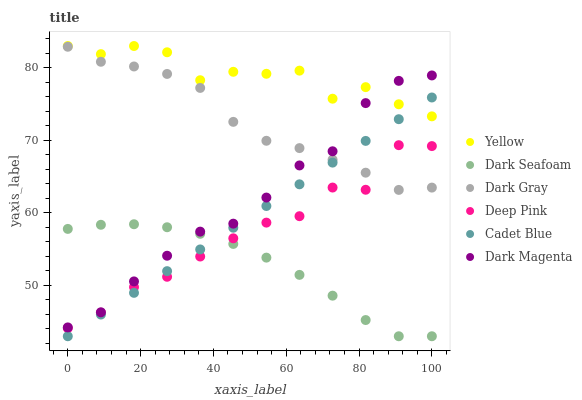Does Dark Seafoam have the minimum area under the curve?
Answer yes or no. Yes. Does Yellow have the maximum area under the curve?
Answer yes or no. Yes. Does Dark Magenta have the minimum area under the curve?
Answer yes or no. No. Does Dark Magenta have the maximum area under the curve?
Answer yes or no. No. Is Cadet Blue the smoothest?
Answer yes or no. Yes. Is Yellow the roughest?
Answer yes or no. Yes. Is Dark Magenta the smoothest?
Answer yes or no. No. Is Dark Magenta the roughest?
Answer yes or no. No. Does Dark Seafoam have the lowest value?
Answer yes or no. Yes. Does Dark Magenta have the lowest value?
Answer yes or no. No. Does Yellow have the highest value?
Answer yes or no. Yes. Does Dark Magenta have the highest value?
Answer yes or no. No. Is Dark Gray less than Yellow?
Answer yes or no. Yes. Is Dark Gray greater than Dark Seafoam?
Answer yes or no. Yes. Does Yellow intersect Dark Magenta?
Answer yes or no. Yes. Is Yellow less than Dark Magenta?
Answer yes or no. No. Is Yellow greater than Dark Magenta?
Answer yes or no. No. Does Dark Gray intersect Yellow?
Answer yes or no. No. 